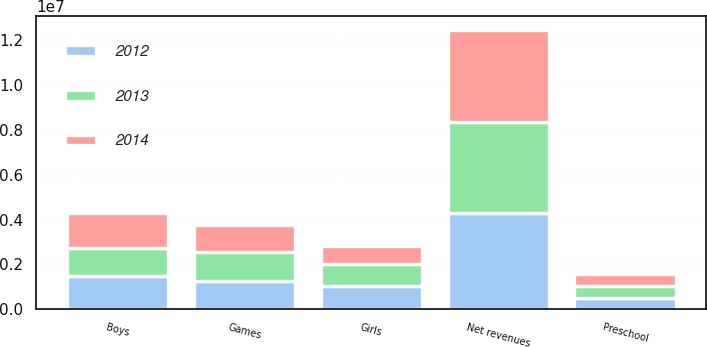<chart> <loc_0><loc_0><loc_500><loc_500><stacked_bar_chart><ecel><fcel>Boys<fcel>Games<fcel>Girls<fcel>Preschool<fcel>Net revenues<nl><fcel>2012<fcel>1.48395e+06<fcel>1.25978e+06<fcel>1.02263e+06<fcel>510840<fcel>4.27721e+06<nl><fcel>2013<fcel>1.23761e+06<fcel>1.3112e+06<fcel>1.0017e+06<fcel>531637<fcel>4.08216e+06<nl><fcel>2014<fcel>1.57701e+06<fcel>1.19209e+06<fcel>792292<fcel>527591<fcel>4.08898e+06<nl></chart> 